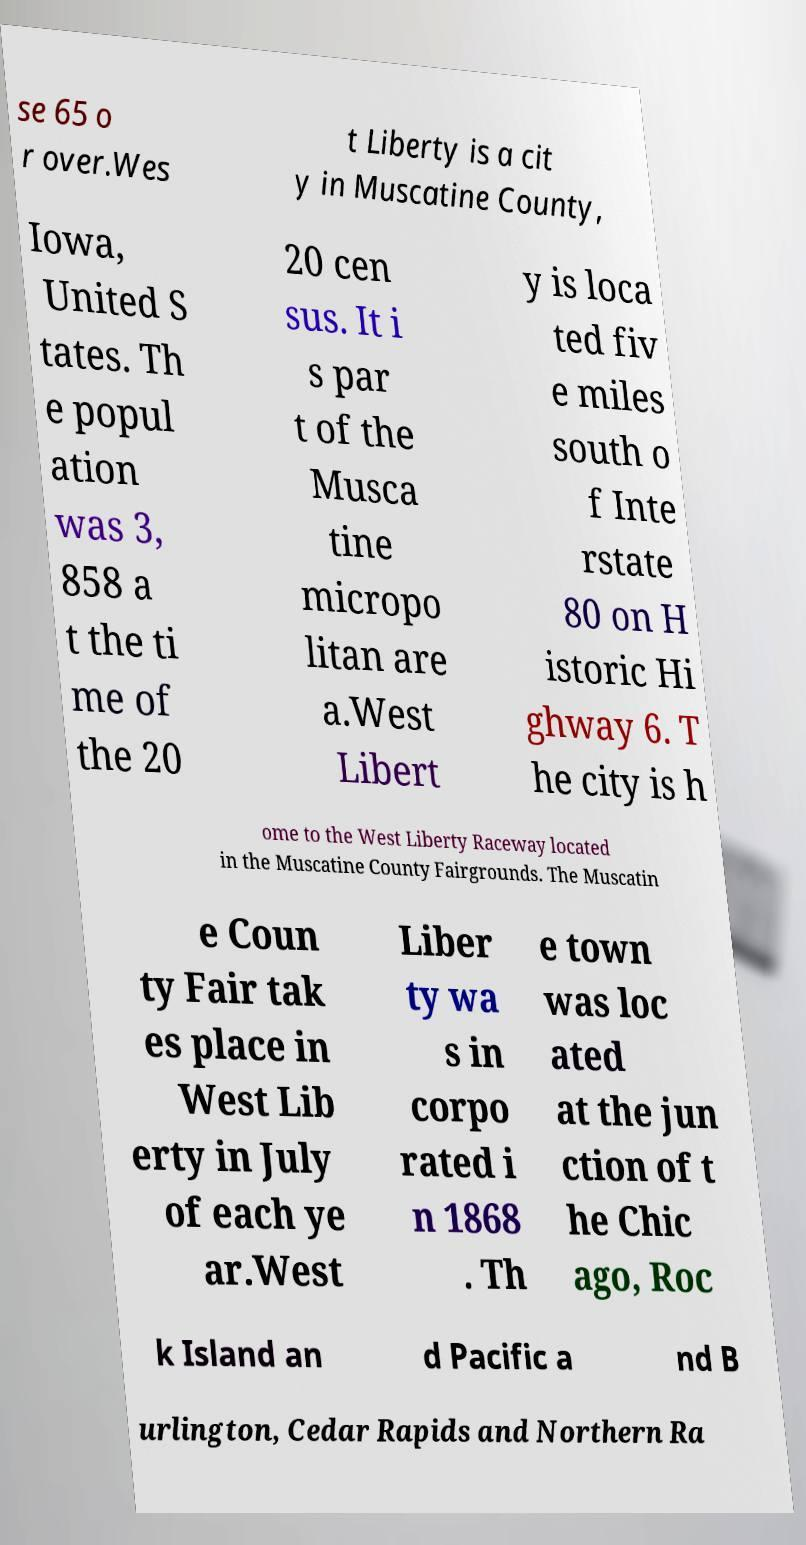Can you read and provide the text displayed in the image?This photo seems to have some interesting text. Can you extract and type it out for me? se 65 o r over.Wes t Liberty is a cit y in Muscatine County, Iowa, United S tates. Th e popul ation was 3, 858 a t the ti me of the 20 20 cen sus. It i s par t of the Musca tine micropo litan are a.West Libert y is loca ted fiv e miles south o f Inte rstate 80 on H istoric Hi ghway 6. T he city is h ome to the West Liberty Raceway located in the Muscatine County Fairgrounds. The Muscatin e Coun ty Fair tak es place in West Lib erty in July of each ye ar.West Liber ty wa s in corpo rated i n 1868 . Th e town was loc ated at the jun ction of t he Chic ago, Roc k Island an d Pacific a nd B urlington, Cedar Rapids and Northern Ra 